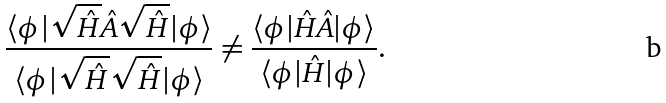<formula> <loc_0><loc_0><loc_500><loc_500>\frac { \langle \phi | \sqrt { \hat { H } } \hat { A } \sqrt { \hat { H } } | \phi \rangle } { \langle \phi | \sqrt { \hat { H } } \sqrt { \hat { H } } | \phi \rangle } \ne \frac { \langle \phi | \hat { H } \hat { A } | \phi \rangle } { \langle \phi | \hat { H } | \phi \rangle } .</formula> 